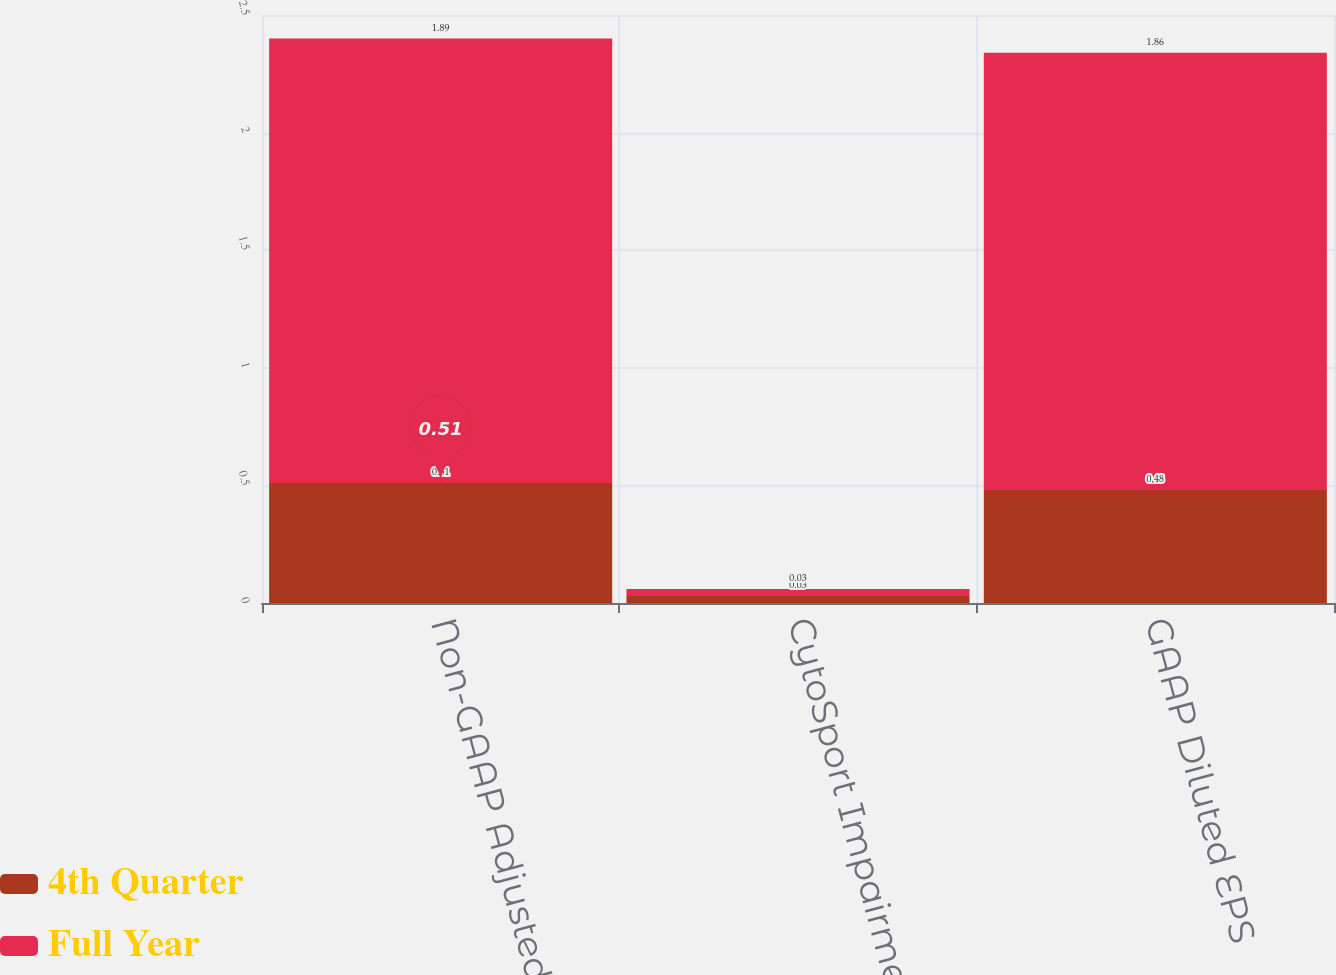<chart> <loc_0><loc_0><loc_500><loc_500><stacked_bar_chart><ecel><fcel>Non-GAAP Adjusted Diluted EPS<fcel>CytoSport Impairment<fcel>GAAP Diluted EPS<nl><fcel>4th Quarter<fcel>0.51<fcel>0.03<fcel>0.48<nl><fcel>Full Year<fcel>1.89<fcel>0.03<fcel>1.86<nl></chart> 